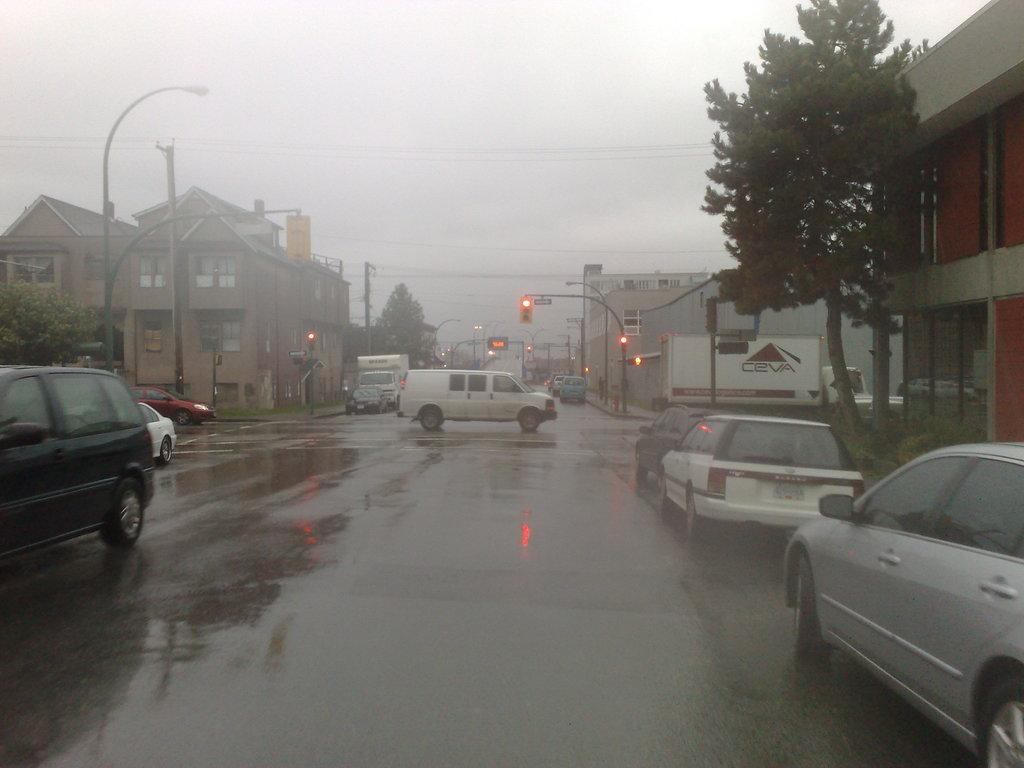What can be seen on the road in the image? There are many vehicles on the road in the image. What types of structures are visible in the image? There are buildings and houses in the image. What natural elements are present in the image? There are trees in the image. What artificial elements are present to aid in visibility and traffic control? There are street lights and traffic signal poles in the image. Can you tell me how many bulbs of cheese are on the traffic signal pole in the image? There are no bulbs of cheese present in the image; the traffic signal poles have lights for traffic control. What direction are the vehicles moving in the image? The image does not provide information about the direction of the vehicles; it only shows that there are many vehicles on the road. 